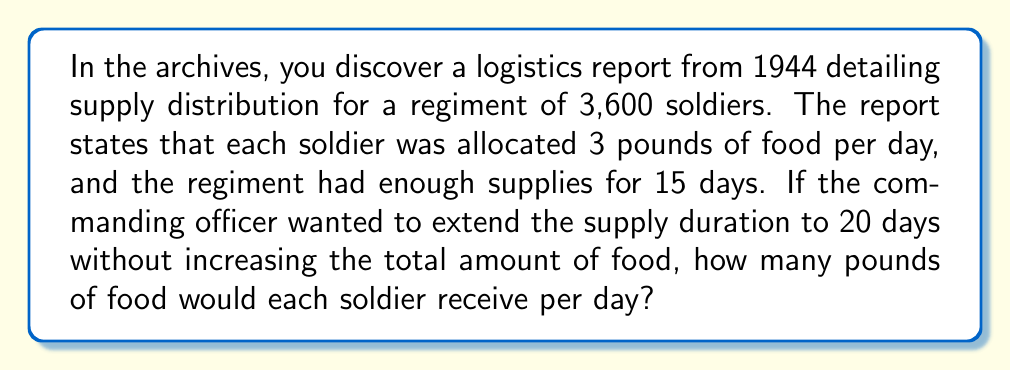Help me with this question. Let's approach this step-by-step:

1. Calculate the total amount of food for the original plan:
   $$ \text{Total food} = 3,600 \text{ soldiers} \times 3 \text{ lbs/day} \times 15 \text{ days} = 162,000 \text{ lbs} $$

2. Set up an equation to find the new daily ration (x) for 20 days:
   $$ 3,600 \text{ soldiers} \times x \text{ lbs/day} \times 20 \text{ days} = 162,000 \text{ lbs} $$

3. Simplify the equation:
   $$ 72,000x = 162,000 $$

4. Solve for x:
   $$ x = \frac{162,000}{72,000} = \frac{9}{4} = 2.25 $$

Therefore, to extend the supply duration to 20 days, each soldier would receive 2.25 pounds of food per day.
Answer: $2.25 \text{ lbs/day}$ 